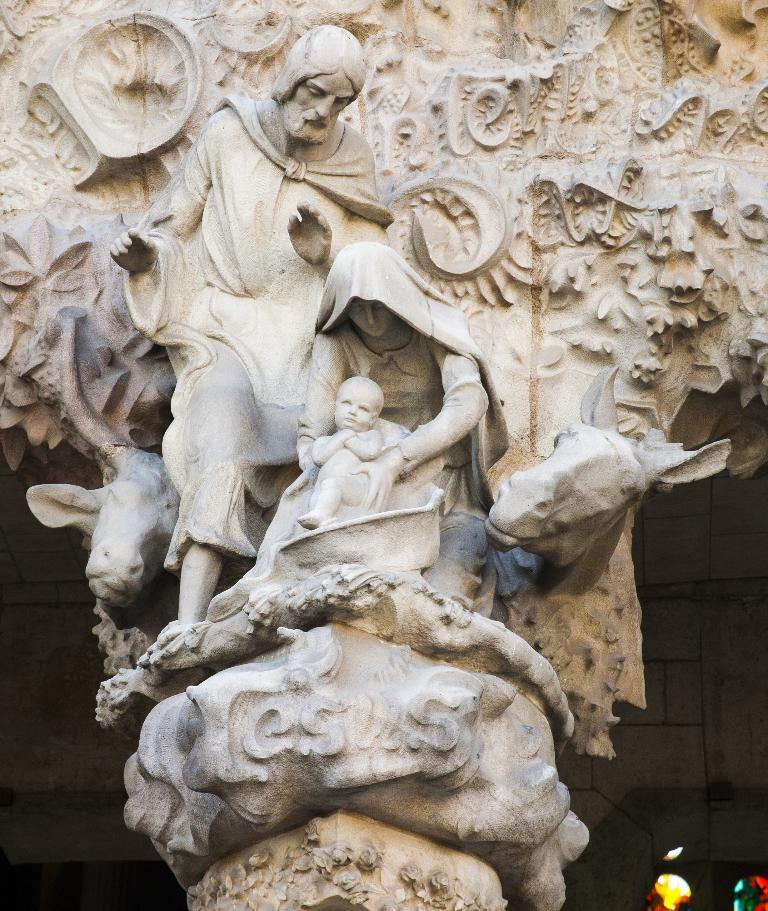How many sculptures are present in the image? There are three sculptures in the image. What type of subjects are depicted in the sculptures? The sculptures include animals. Is there any text visible in the image? Yes, there is text written on a stone in the image. Can you tell me how many carriages are depicted in the image? There are no carriages present in the image. What type of man is shown interacting with the sculptures in the image? There is no man present in the image; it only features sculptures and text on a stone. 